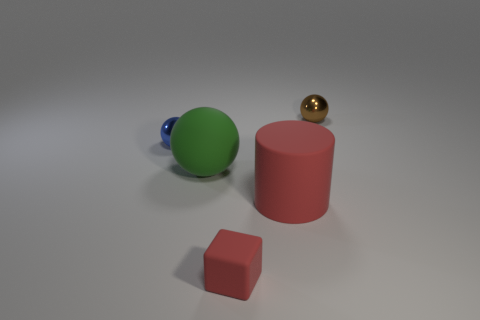Subtract all purple balls. Subtract all red cylinders. How many balls are left? 3 Add 5 red matte objects. How many objects exist? 10 Subtract all blocks. How many objects are left? 4 Subtract 0 yellow balls. How many objects are left? 5 Subtract all brown rubber things. Subtract all green things. How many objects are left? 4 Add 5 large red matte things. How many large red matte things are left? 6 Add 5 cylinders. How many cylinders exist? 6 